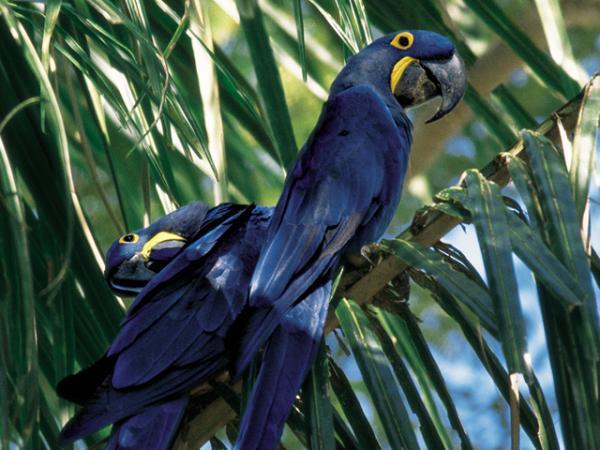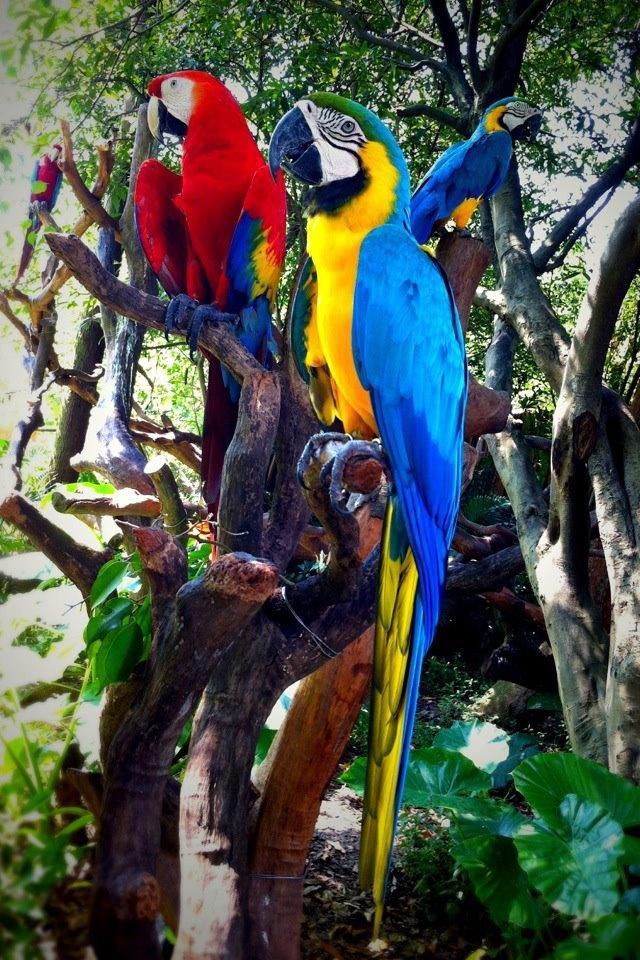The first image is the image on the left, the second image is the image on the right. For the images shown, is this caption "One image includes a red-headed bird and a bird with blue-and-yellow coloring." true? Answer yes or no. Yes. The first image is the image on the left, the second image is the image on the right. Considering the images on both sides, is "Two blue birds are perched on a branch in the image on the left." valid? Answer yes or no. Yes. 